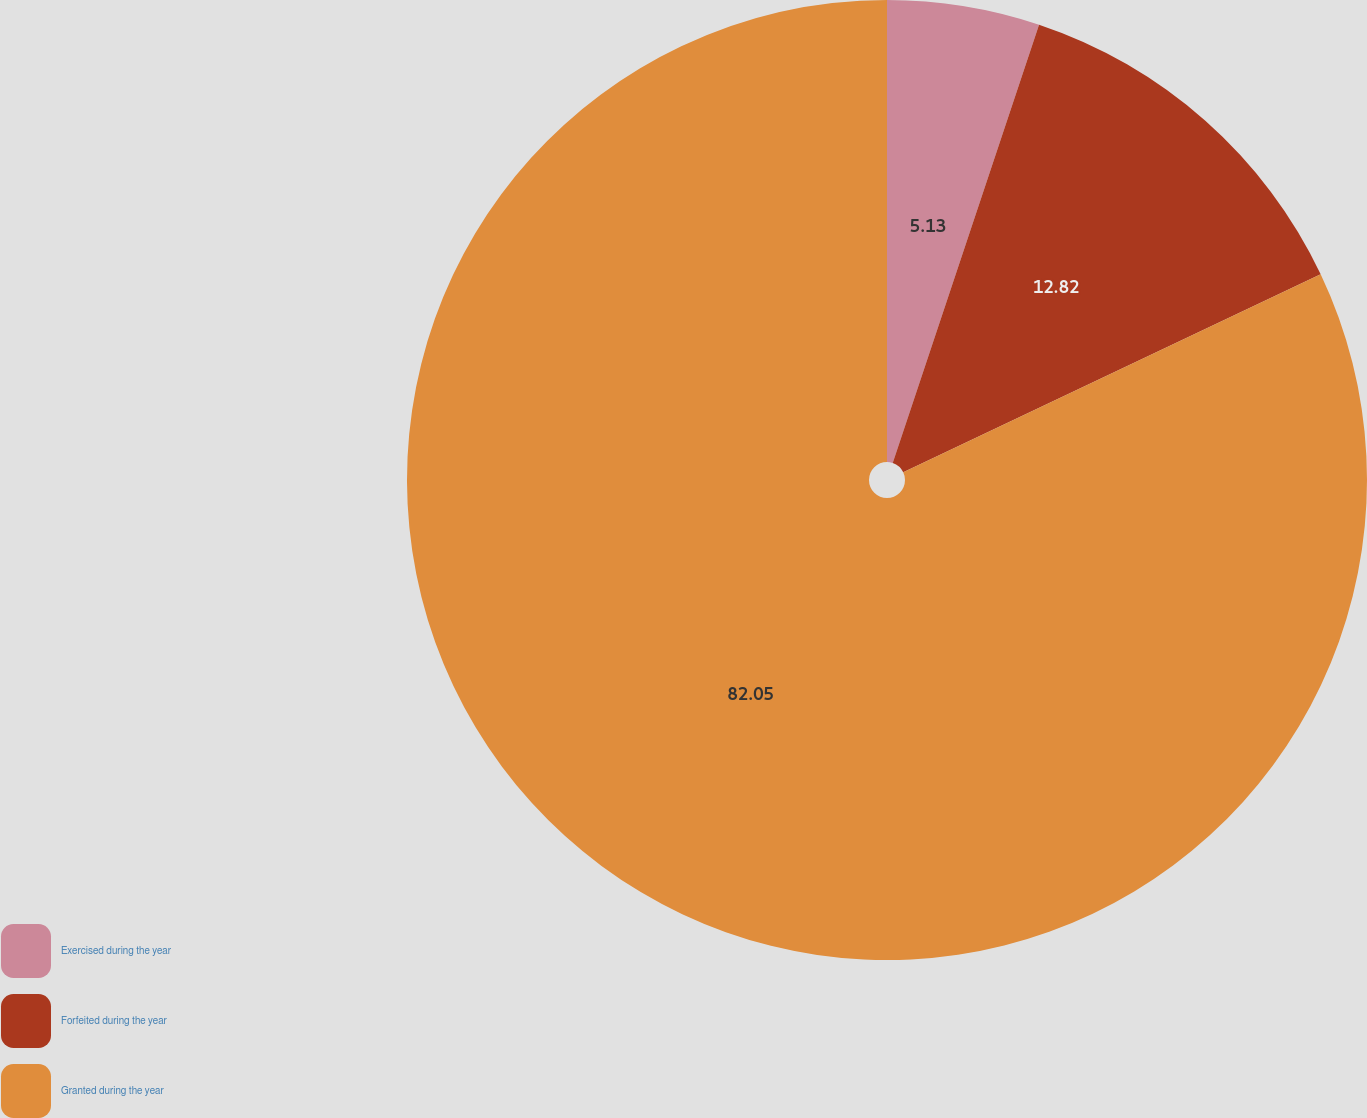<chart> <loc_0><loc_0><loc_500><loc_500><pie_chart><fcel>Exercised during the year<fcel>Forfeited during the year<fcel>Granted during the year<nl><fcel>5.13%<fcel>12.82%<fcel>82.05%<nl></chart> 